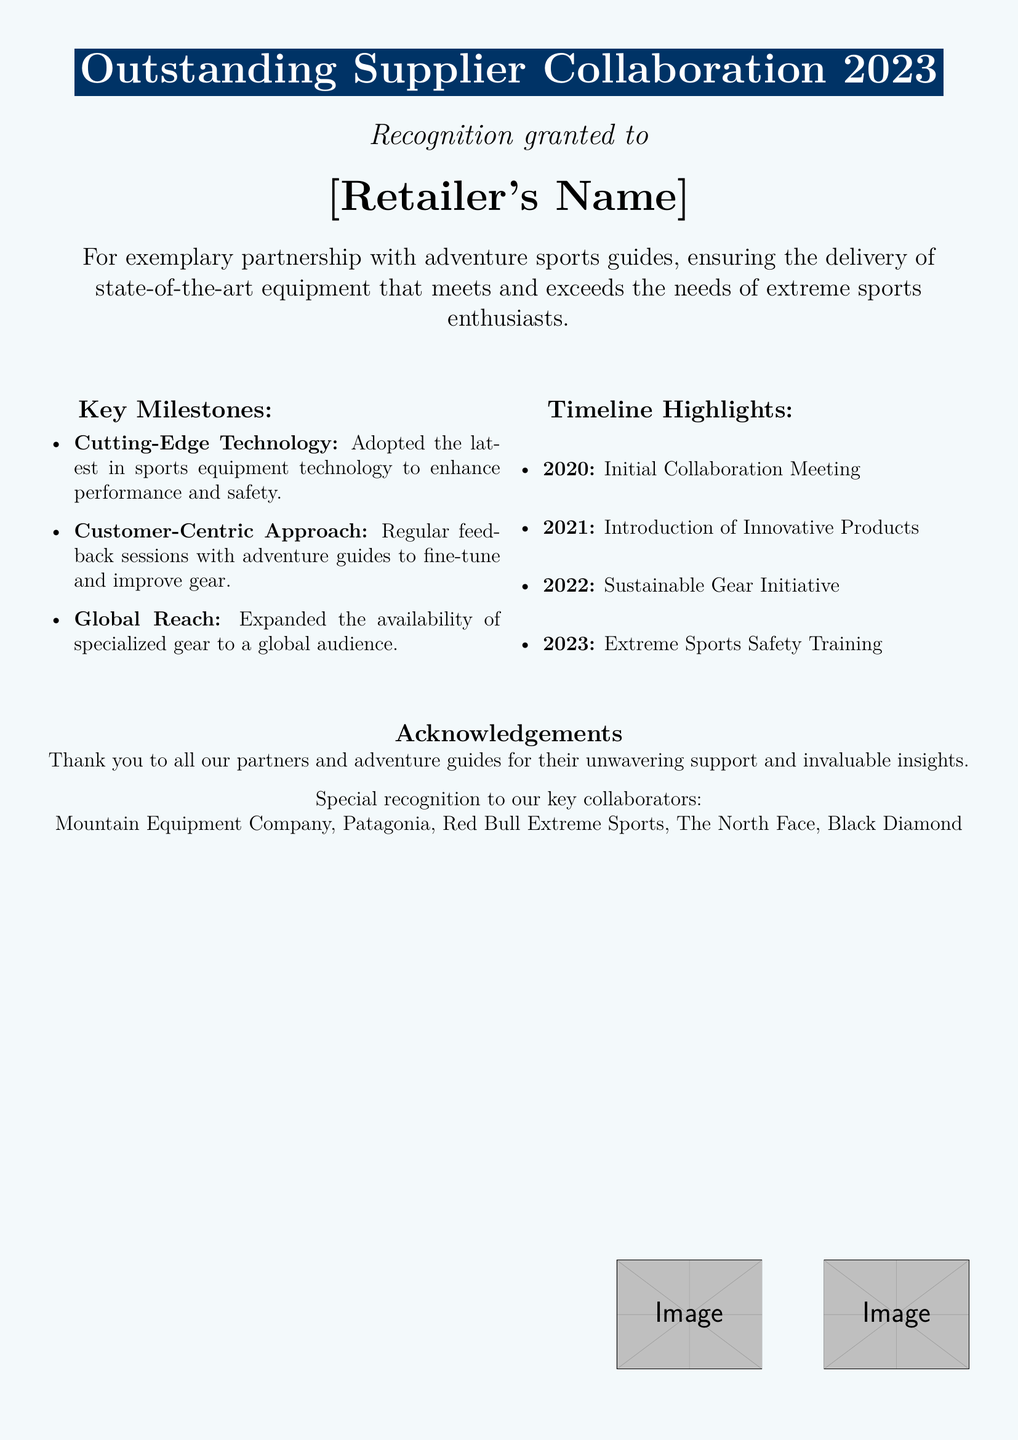What is the title of the certificate? The title of the certificate is the heading that recognizes the achievement, which is "Outstanding Supplier Collaboration 2023."
Answer: Outstanding Supplier Collaboration 2023 Who is the certificate granted to? The certificate recognizes the retailer's core achievement by explicitly mentioning their name in a prominent way.
Answer: [Retailer's Name] What year marks the initial collaboration meeting? The timeline highlights sections list key events with specific years, including the initial collaboration meeting in 2020.
Answer: 2020 What was introduced in 2021? The timeline highlights for the year 2021 indicate a specific milestone related to new offerings within the collaboration.
Answer: Introduction of Innovative Products Which initiative was launched in 2022? A specific milestone listed in the timeline shows the focus on sustainability for that year.
Answer: Sustainable Gear Initiative What is one key milestone highlighted in the document? The key milestones section includes various important achievements, of which one example is stated.
Answer: Cutting-Edge Technology Who are some of the key collaborators acknowledged in the certificate? The acknowledgements section lists specific partners credited for their essential contributions to the initiative.
Answer: Mountain Equipment Company, Patagonia, Red Bull Extreme Sports, The North Face, Black Diamond What type of training was emphasized in 2023? The document outlines a new focus area for that year that centers around improving safety measures for sports enthusiasts.
Answer: Extreme Sports Safety Training What is the color theme of the certificate? The document includes a description of the background color used throughout the certificate, which is set in a specific tone.
Answer: Light blue 